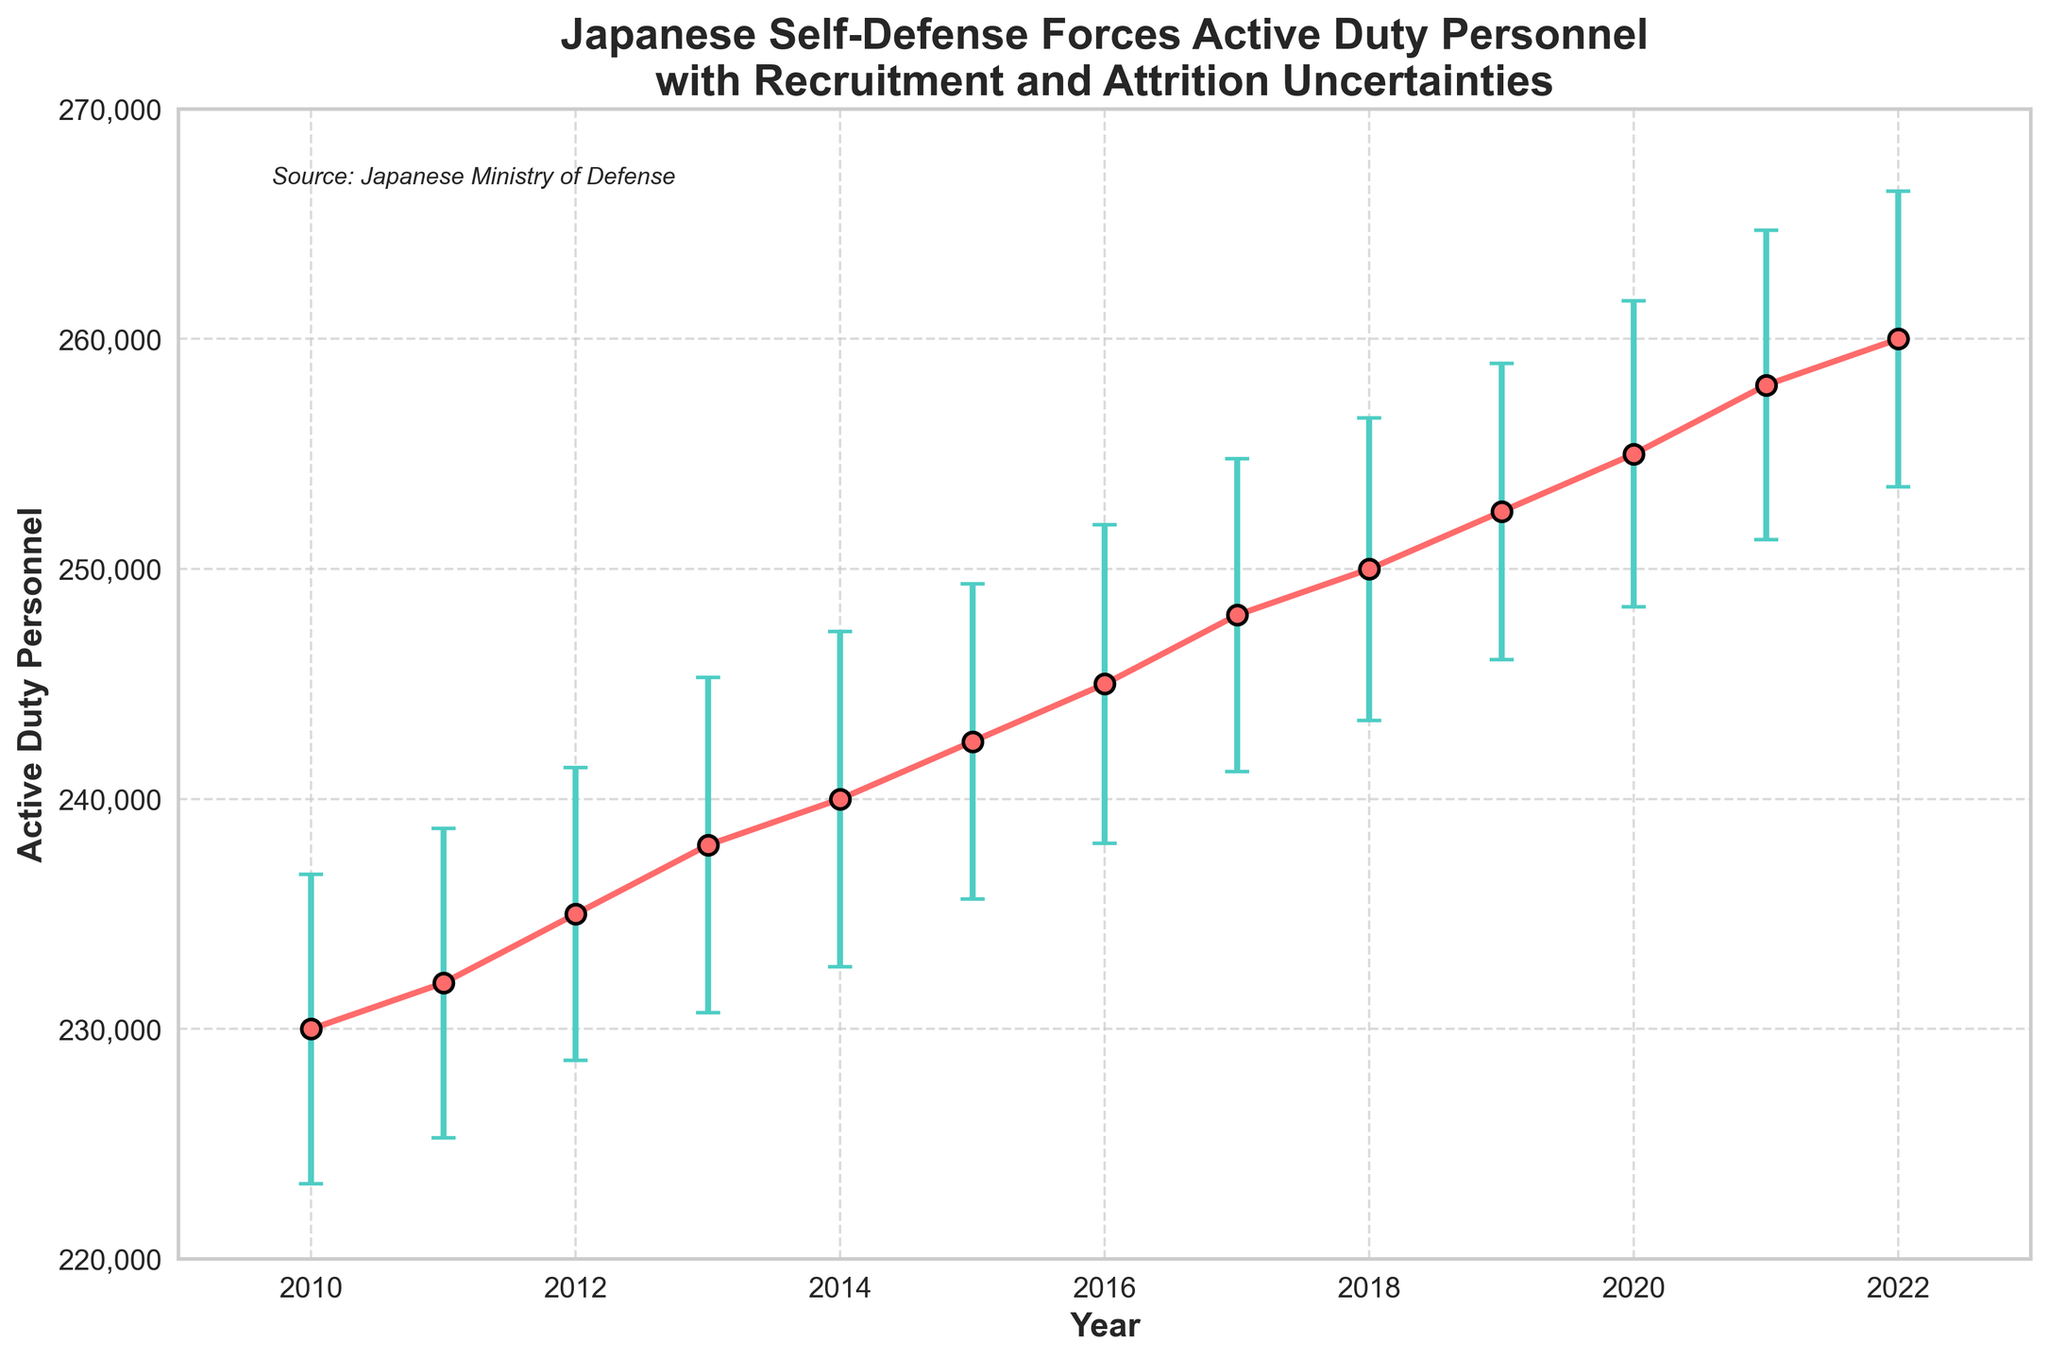What is the title of the plot? The title of the plot is located at the top of the figure. It provides a brief description of what the plot is about.
Answer: Japanese Self-Defense Forces Active Duty Personnel with Recruitment and Attrition Uncertainties What is the range of years displayed on the x-axis? The x-axis represents the years for which the data is plotted. The range can be seen from the beginning to the end of the axis.
Answer: 2010 to 2022 What is the highest number of active duty personnel and in which year does it occur? Look at the point with the maximum y-value and note the corresponding year on the x-axis.
Answer: 260,000 in 2022 Between which two consecutive years did the active duty personnel experience the largest increase? Calculate the difference in active duty personnel between each pair of consecutive years and identify the pair with the largest difference.
Answer: 2021 to 2022 What is the uncertainty range for the year 2015? Add and subtract the error value from the number of active duty personnel for 2015.
Answer: [237,600, 247,400] How does the trend of active duty personnel numbers change over the years? Observe the overall pattern of the plotted points and error bars from left to right.
Answer: It shows a consistent increase In which year did the active duty personnel number around 242,500? Identify the x-axis (year) corresponding to the y-axis value of approximately 242,500.
Answer: 2015 Compare the recruitment and attrition uncertainties for the year 2020. Which one is higher? Refer to the error values for recruitment and attrition uncertainties provided in the data for 2020.
Answer: Attrition uncertainty (4800) is higher Which year has the lowest total uncertainty and what is its value? Calculate the total uncertainty for each year using the provided formula and identify the minimum value and corresponding year.
Answer: 2022, ±6,383.95 How does the plot indicate the recruitment and attrition uncertainties? Look for the visual representation (error bars) indicating uncertainty around each data point.
Answer: Error bars using red color for data points and green color for uncertainty 